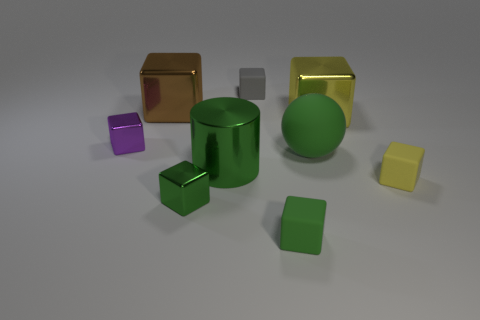Subtract all purple blocks. How many blocks are left? 6 Subtract all brown metal blocks. How many blocks are left? 6 Subtract all yellow cubes. Subtract all brown cylinders. How many cubes are left? 5 Add 1 tiny purple rubber cubes. How many objects exist? 10 Subtract all blocks. How many objects are left? 2 Add 6 green balls. How many green balls exist? 7 Subtract 0 gray cylinders. How many objects are left? 9 Subtract all small yellow matte things. Subtract all large green rubber spheres. How many objects are left? 7 Add 7 green rubber spheres. How many green rubber spheres are left? 8 